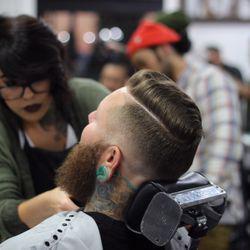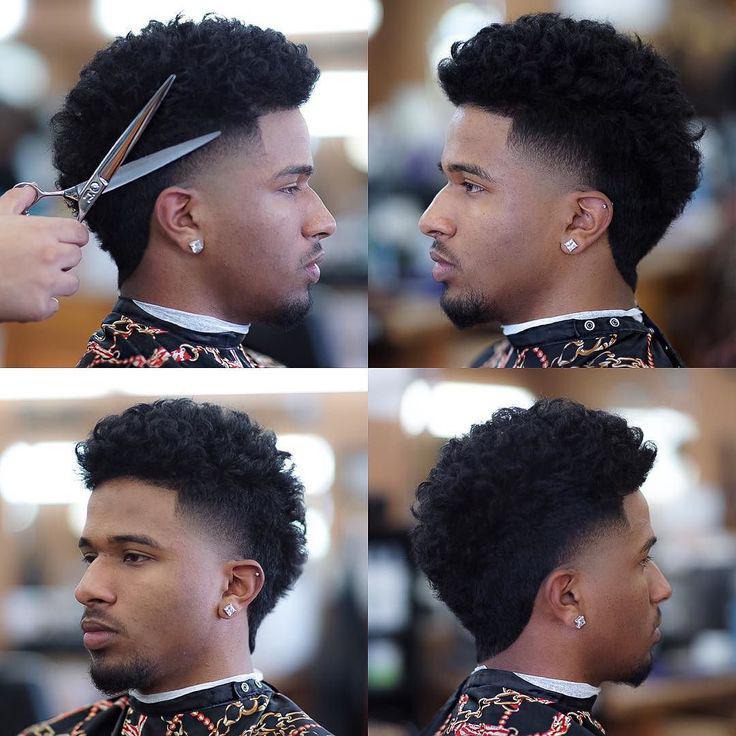The first image is the image on the left, the second image is the image on the right. Analyze the images presented: Is the assertion "At least one image shows a male barber standing to work on a customer's hair." valid? Answer yes or no. No. 